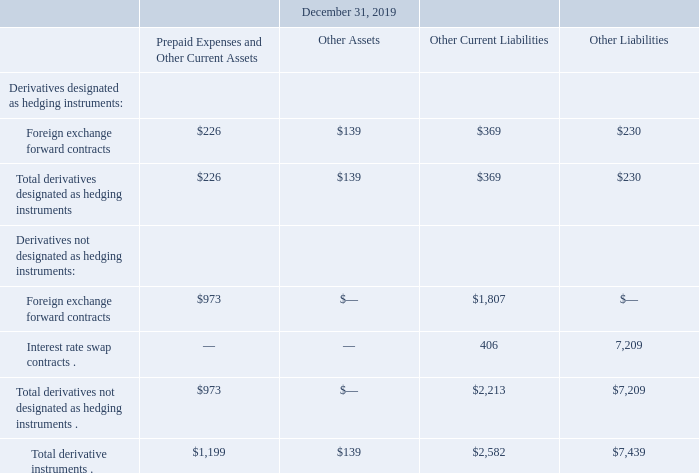9. Derivative Financial Instruments
As a global company, we are exposed in the normal course of business to interest rate and foreign currency risks that could affect our financial position, results of operations, and cash flows. We use derivative instruments to hedge against these risks and only hold such instruments for hedging purposes, not for speculative or trading purposes.
Depending on the terms of the specific derivative instruments and market conditions, some of our derivative instruments may be assets and others liabilities at any particular balance sheet date. We report all of our derivative instruments at fair value and account for changes in the fair value of derivative instruments within “Accumulated other comprehensive loss” if the derivative instruments qualify for hedge accounting. For those derivative instruments that do not qualify for hedge accounting (i.e., “economic hedges”), we record the changes in fair value directly to earnings. See Note 11. “Fair Value Measurements” to our consolidated financial statements for information about the techniques we use to measure the fair value of our derivative instruments.
The following tables present the fair values of derivative instruments included in our consolidated balance sheets as of December 31, 2019 and 2018 (in thousands):
How are changes in fair value of hedging instruments accounted for? Within “accumulated other comprehensive loss”. What risks are hedged using the derivative instruments? Interest rate and foreign currency risks. What is the total derivate instruments for other liabilities?
Answer scale should be: thousand. $7,439. What is the difference in the total derivative instruments between other assets and other current liabilities?
Answer scale should be: thousand. 139-2,582
Answer: -2443. Under prepaid expenses and other current assets, what is the ratio of the total derivates designated as hedging instruments to those not designated as hedging instruments? 226/973
Answer: 0.23. What is the difference in the foreign exchange forward contracts for hedging instruments between other assets and other liabilities?
Answer scale should be: thousand. 139-230
Answer: -91. 